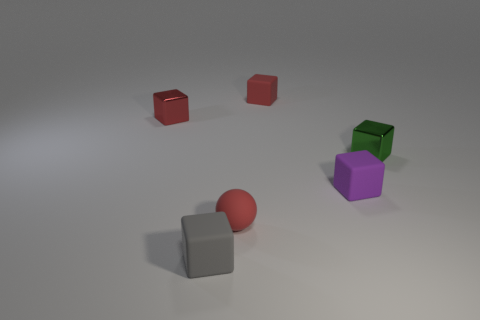Are there more big cyan spheres than small gray objects? Upon examining the image, it appears that there is only one large cyan sphere visible amongst the objects. Regarding small gray objects, there are two present. Therefore, the answer to your question is that there are more small gray objects than large cyan spheres. 